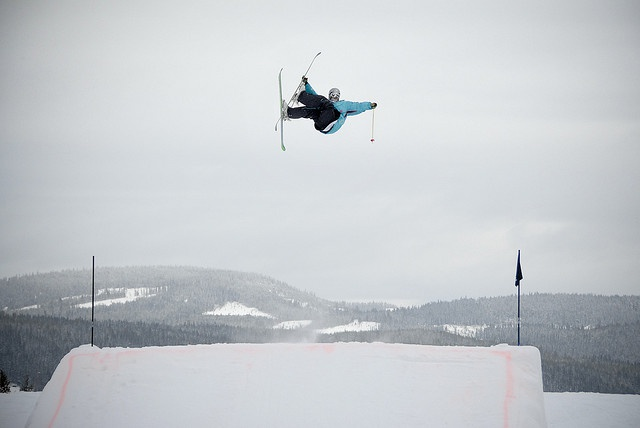Describe the objects in this image and their specific colors. I can see people in gray, black, teal, darkgray, and lightgray tones and skis in gray, darkgray, and lightgray tones in this image. 